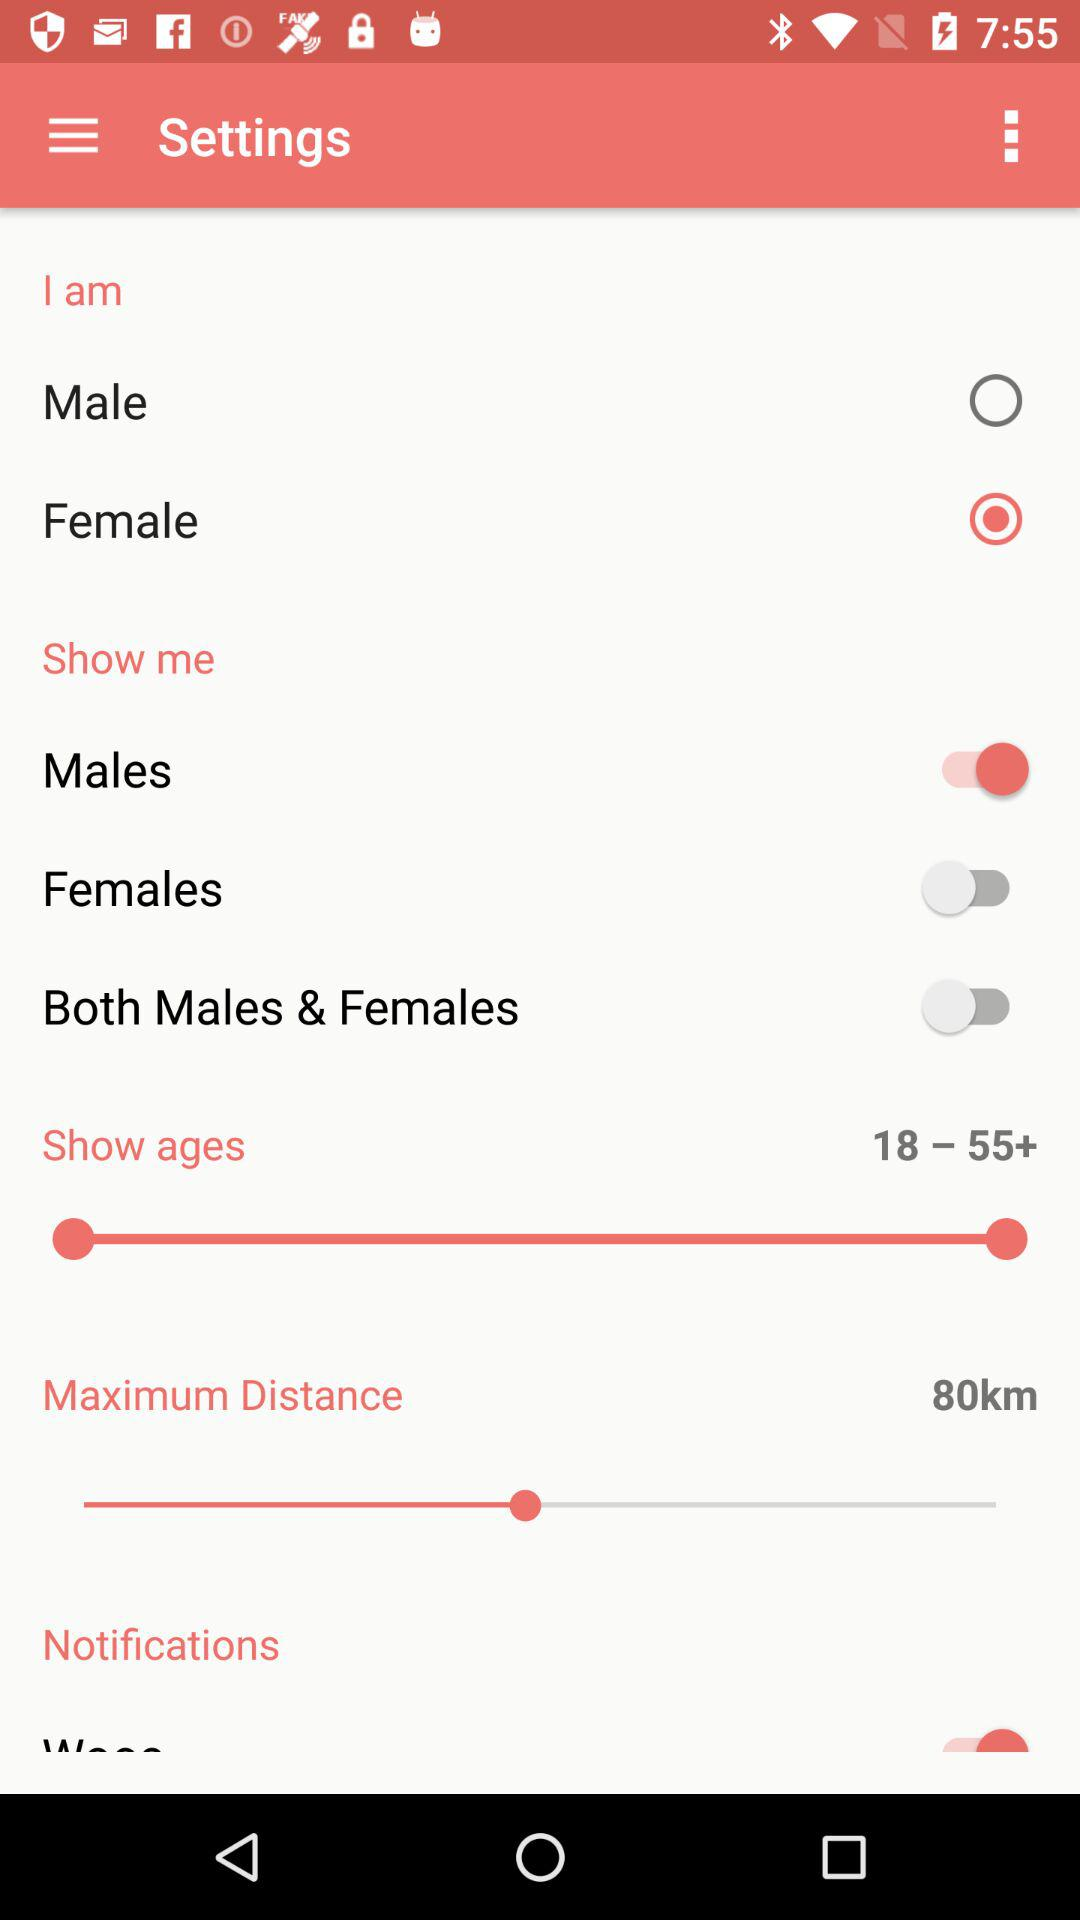What is the gender option? The gender options are "Male" and "Female". 